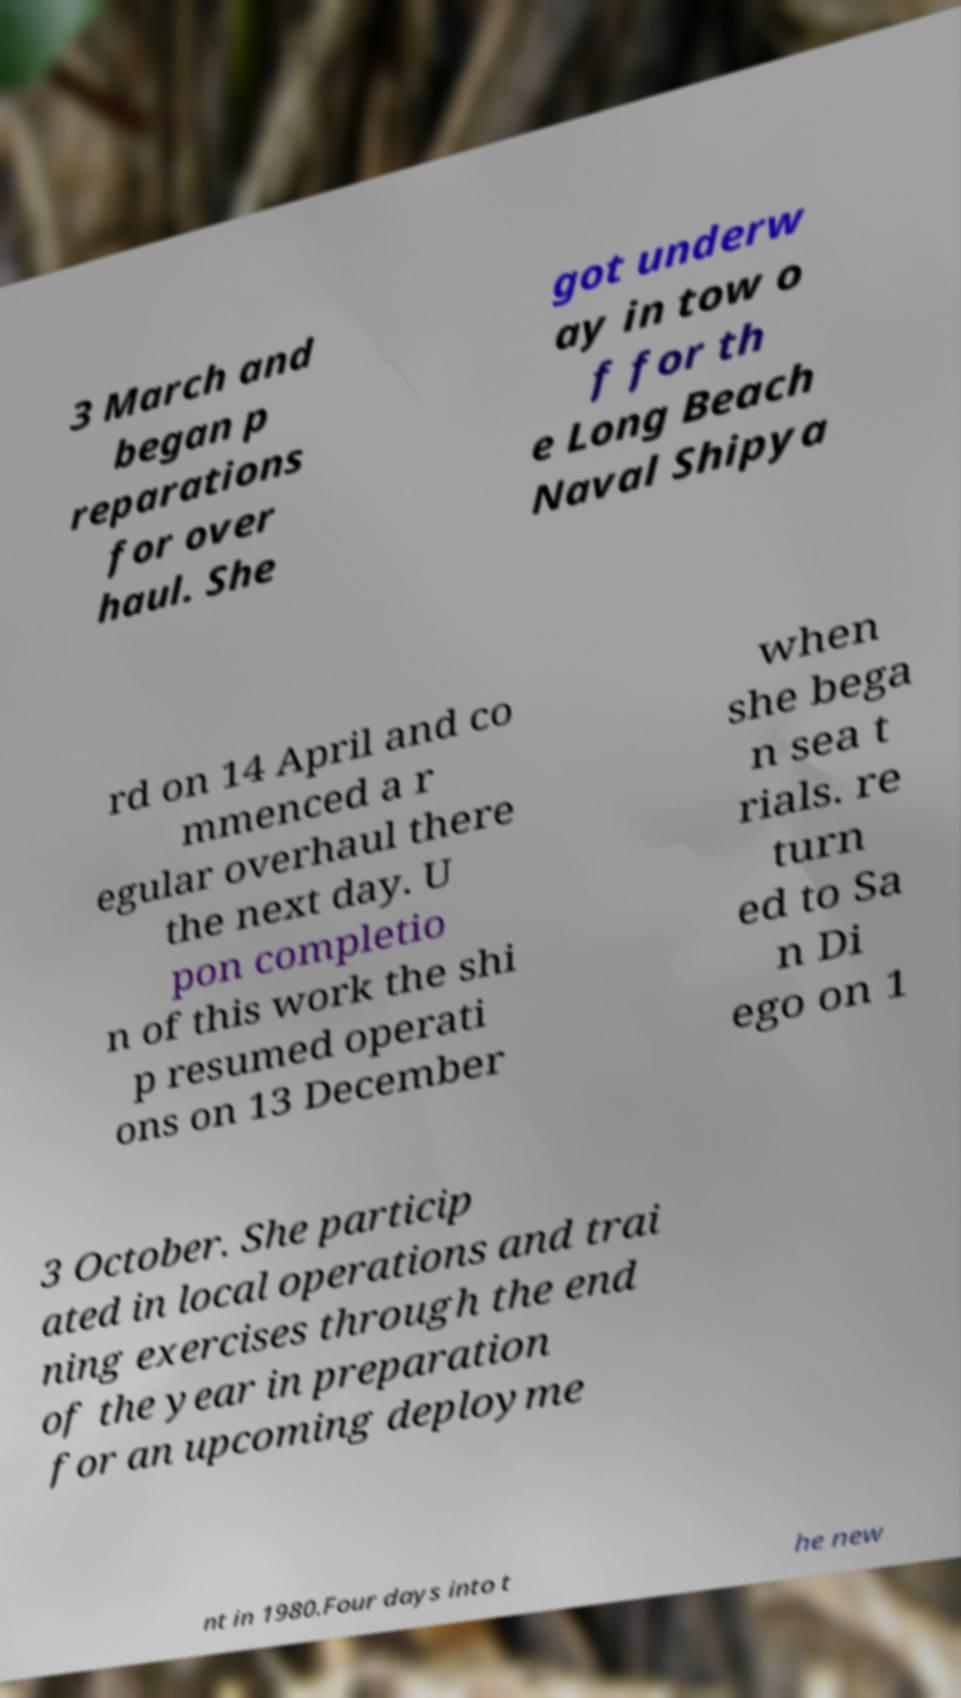Please identify and transcribe the text found in this image. 3 March and began p reparations for over haul. She got underw ay in tow o f for th e Long Beach Naval Shipya rd on 14 April and co mmenced a r egular overhaul there the next day. U pon completio n of this work the shi p resumed operati ons on 13 December when she bega n sea t rials. re turn ed to Sa n Di ego on 1 3 October. She particip ated in local operations and trai ning exercises through the end of the year in preparation for an upcoming deployme nt in 1980.Four days into t he new 